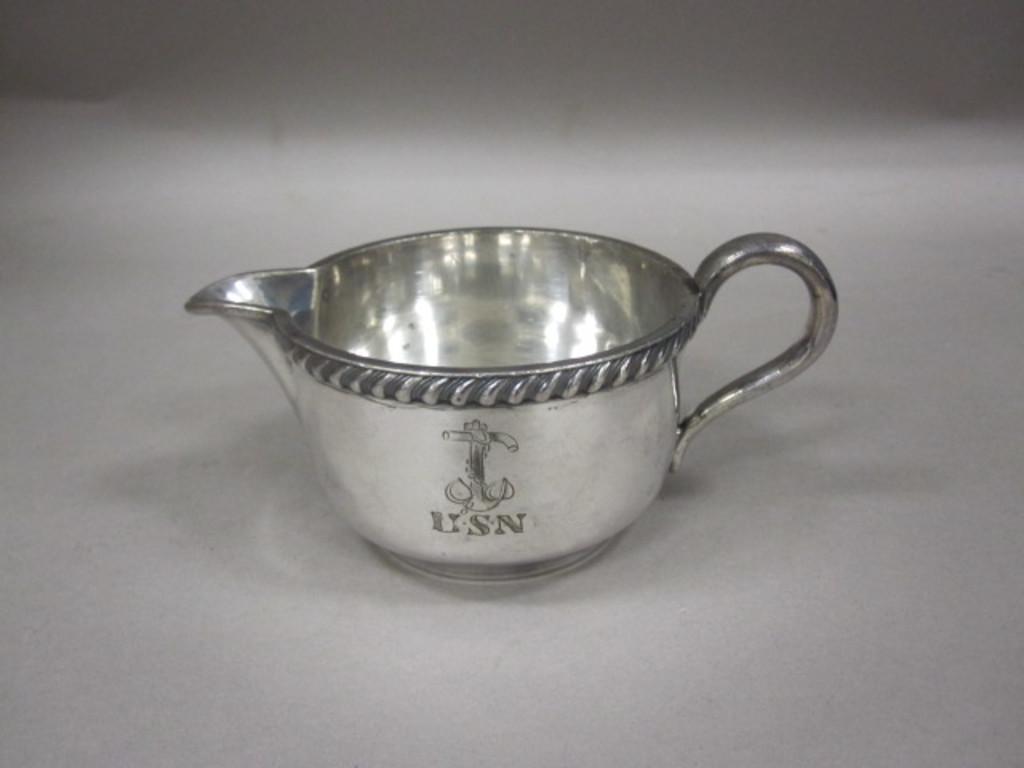What letters are on the silver cup?
Keep it short and to the point. Usn. What letters are on the teacup?
Your answer should be compact. Usn. 